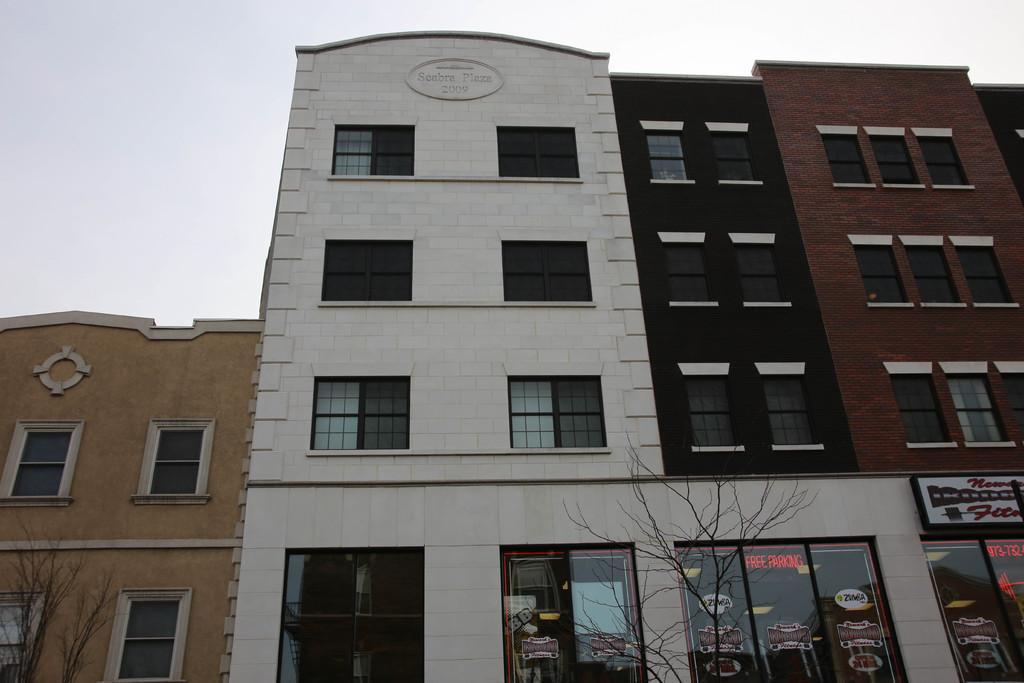Please provide a concise description of this image. On the left side of the image we have a cream color building. In the middle of the image we have a white color building and a text written on it. On the right side of the image we can see a brick block building. 